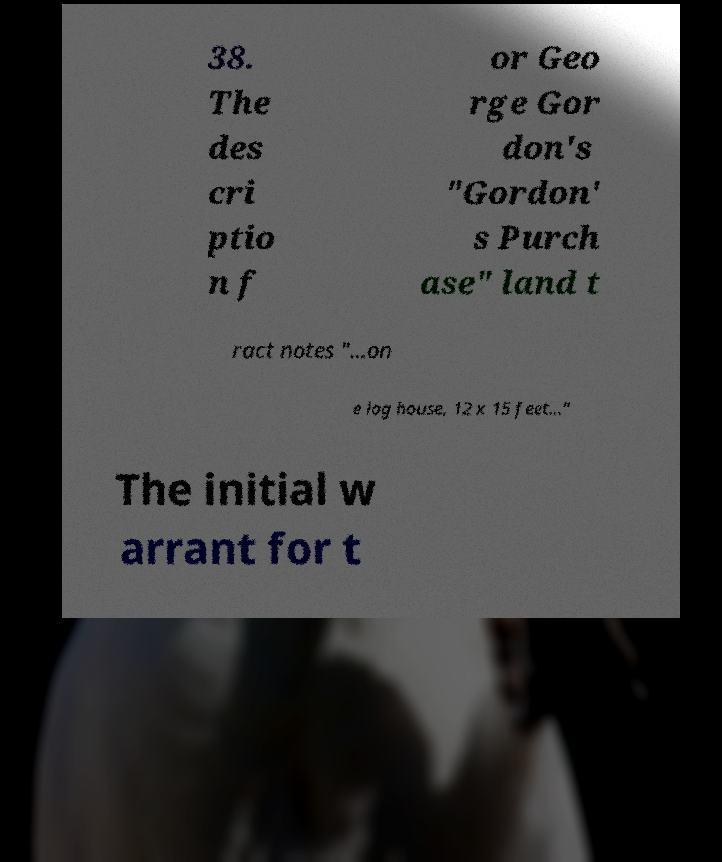Can you accurately transcribe the text from the provided image for me? 38. The des cri ptio n f or Geo rge Gor don's "Gordon' s Purch ase" land t ract notes "...on e log house, 12 x 15 feet..." The initial w arrant for t 